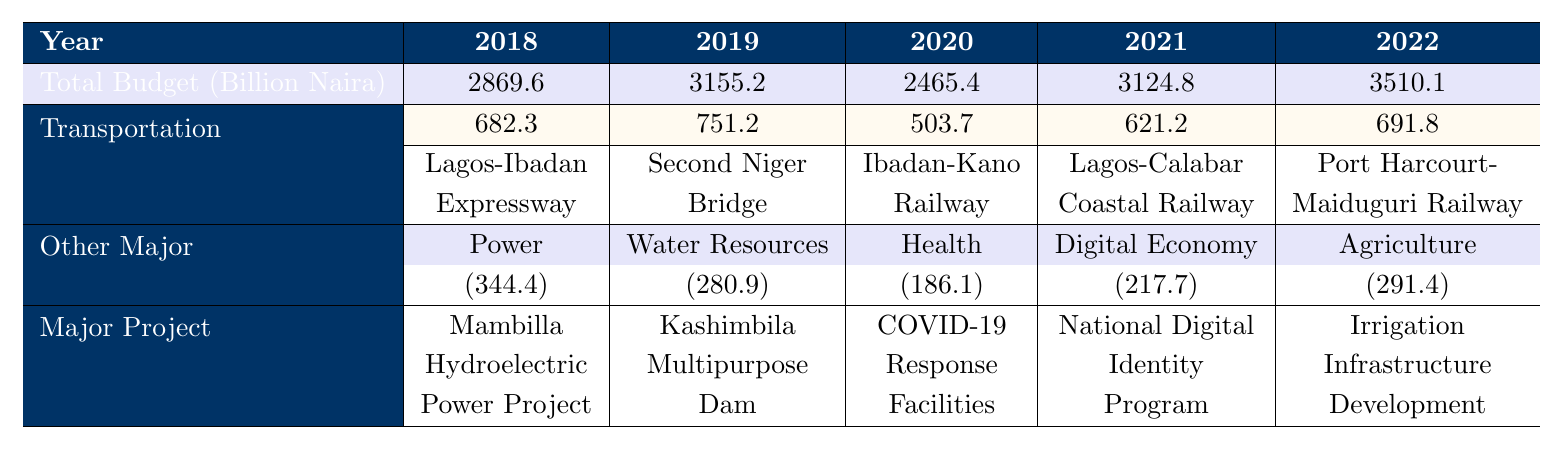What's the total budget for 2020? The table shows that the total budget for 2020 is clearly stated under the "Total Budget (Billion Naira)" row. The value listed for 2020 is 2465.4 billion Naira.
Answer: 2465.4 billion Naira How much was allocated to the Transportation category in 2019? Referring to the 2019 column under "Transportation Allocation (Billion Naira)", we see that the allocation was 751.2 billion Naira.
Answer: 751.2 billion Naira Which year had the highest total budget? By comparing the total budget values across all years, we find that 2022 has the highest total budget at 3510.1 billion Naira.
Answer: 2022 What is the difference in Transportation allocation between 2018 and 2022? The Transportation allocation for 2018 is 682.3 billion Naira and for 2022 it’s 691.8 billion Naira. The difference is calculated as 691.8 - 682.3 = 9.5 billion Naira.
Answer: 9.5 billion Naira Did the government allocate more to Power projects in 2021 than to Water Resources in 2019? In 2021, the allocation for Power projects is not specified in the 2021 section. However, looking closely, it reveals that the allocation for Water Resources in 2019 was 280.9 billion Naira with no allocation for Power in 2021, therefore it is true that Water Resources received more funding.
Answer: Yes Which category had the least total allocation from 2018 to 2022, and what was that total? Summing the allocations in each category over the years shows that Health in 2020 had the least allocation of 186.1 billion Naira, as compared to other categories in other years.
Answer: Health, 186.1 billion Naira Which project received the highest allocation in the Power category in 2018? Looking at the Power category in 2018, the Mambilla Hydroelectric Power Project had the highest cost listed at 198.7 billion Naira.
Answer: Mambilla Hydroelectric Power Project, 198.7 billion Naira What was the total allocation for Agriculture projects in 2022? In 2022, the only category listed under Agriculture has an allocation of 291.4 billion Naira as stated directly under the respective section.
Answer: 291.4 billion Naira How does the total allocation for Transportation in 2021 compare to that in 2020? For 2021, the Transportation allocation is 621.2 billion Naira while in 2020 it was 503.7 billion Naira. The comparison shows that 621.2 > 503.7, indicating an increase.
Answer: Increased What was the cumulative allocation for Digital Economy projects across all years? The table doesn’t have Digital Economy projects listed for years other than 2021. The allocation in 2021 is 217.7 billion Naira, so the total allocation is also 217.7 billion Naira as there are no other years to sum.
Answer: 217.7 billion Naira 